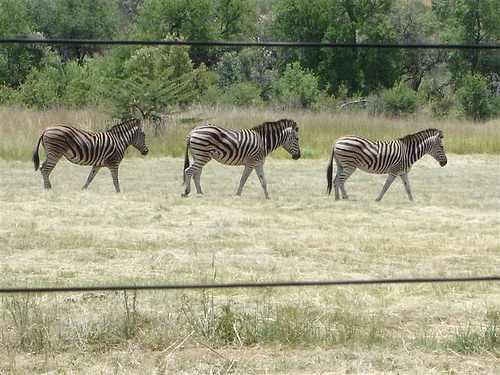Describe the objects in this image and their specific colors. I can see zebra in gray, black, and darkgray tones, zebra in gray, black, and darkgray tones, and zebra in gray, black, and darkgray tones in this image. 